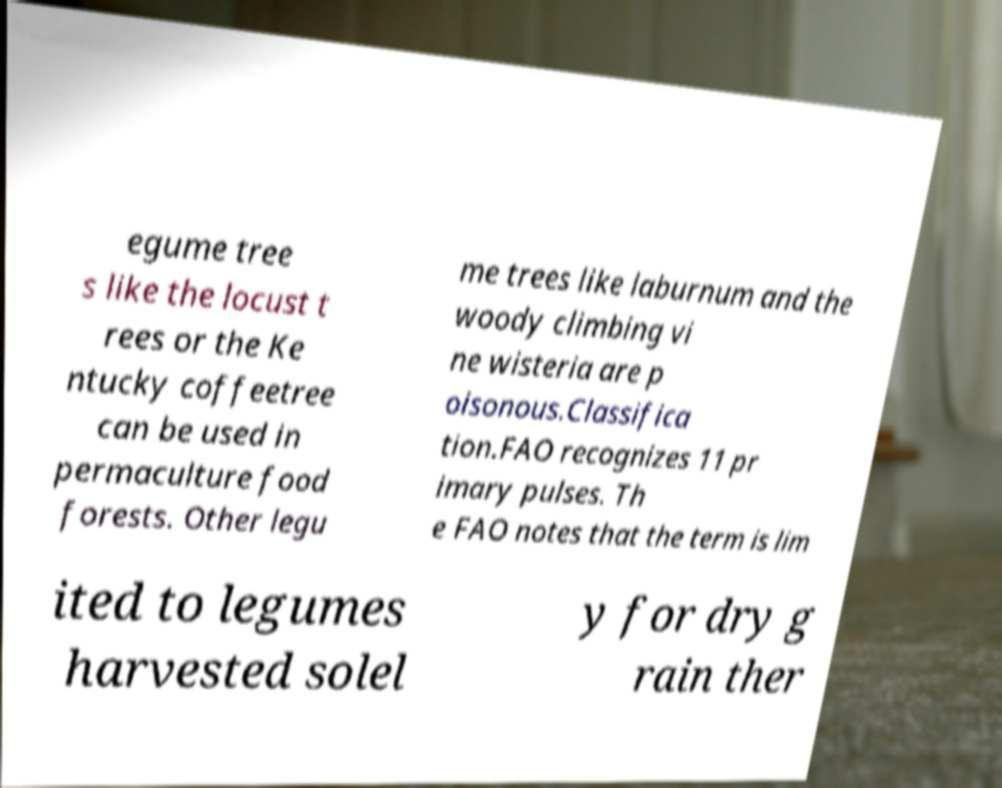What messages or text are displayed in this image? I need them in a readable, typed format. egume tree s like the locust t rees or the Ke ntucky coffeetree can be used in permaculture food forests. Other legu me trees like laburnum and the woody climbing vi ne wisteria are p oisonous.Classifica tion.FAO recognizes 11 pr imary pulses. Th e FAO notes that the term is lim ited to legumes harvested solel y for dry g rain ther 